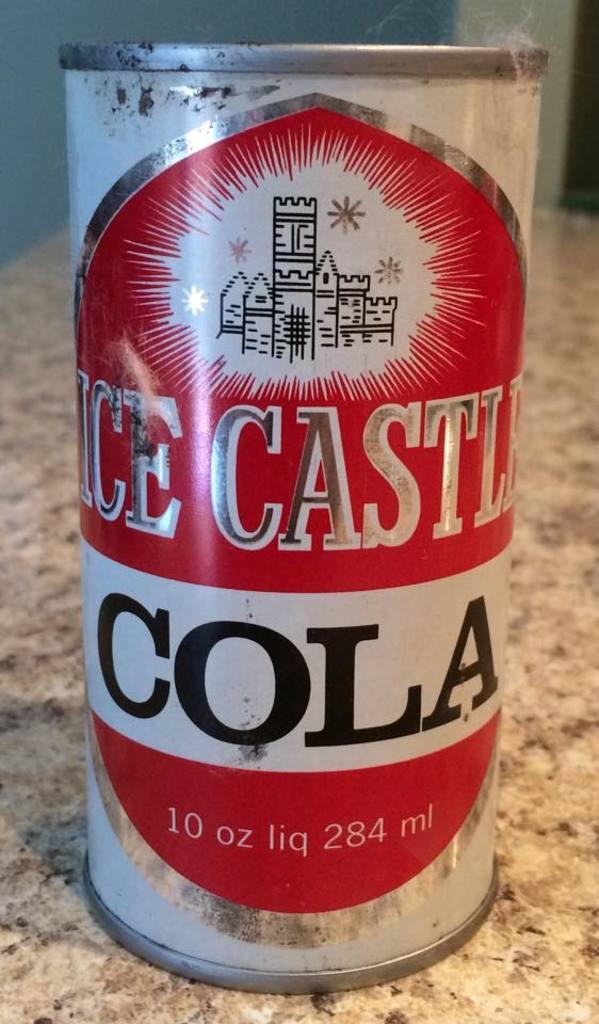How many milliliters is in this drink?
Ensure brevity in your answer.  284. What is the brand of this coke?
Offer a terse response. Ice castle. 